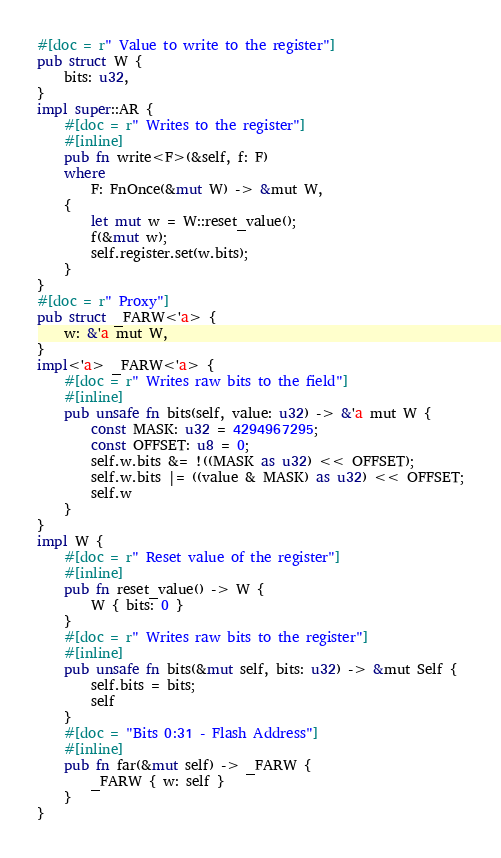<code> <loc_0><loc_0><loc_500><loc_500><_Rust_>#[doc = r" Value to write to the register"]
pub struct W {
    bits: u32,
}
impl super::AR {
    #[doc = r" Writes to the register"]
    #[inline]
    pub fn write<F>(&self, f: F)
    where
        F: FnOnce(&mut W) -> &mut W,
    {
        let mut w = W::reset_value();
        f(&mut w);
        self.register.set(w.bits);
    }
}
#[doc = r" Proxy"]
pub struct _FARW<'a> {
    w: &'a mut W,
}
impl<'a> _FARW<'a> {
    #[doc = r" Writes raw bits to the field"]
    #[inline]
    pub unsafe fn bits(self, value: u32) -> &'a mut W {
        const MASK: u32 = 4294967295;
        const OFFSET: u8 = 0;
        self.w.bits &= !((MASK as u32) << OFFSET);
        self.w.bits |= ((value & MASK) as u32) << OFFSET;
        self.w
    }
}
impl W {
    #[doc = r" Reset value of the register"]
    #[inline]
    pub fn reset_value() -> W {
        W { bits: 0 }
    }
    #[doc = r" Writes raw bits to the register"]
    #[inline]
    pub unsafe fn bits(&mut self, bits: u32) -> &mut Self {
        self.bits = bits;
        self
    }
    #[doc = "Bits 0:31 - Flash Address"]
    #[inline]
    pub fn far(&mut self) -> _FARW {
        _FARW { w: self }
    }
}
</code> 